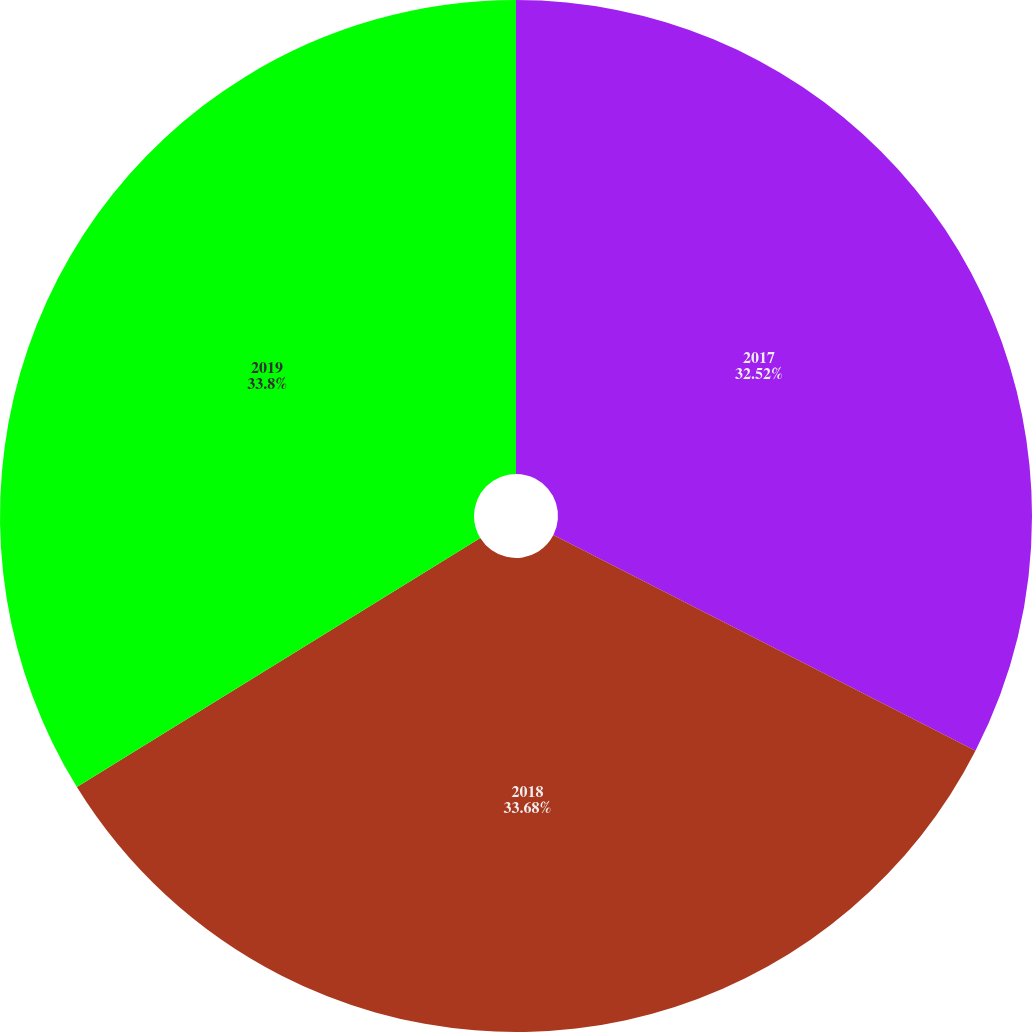<chart> <loc_0><loc_0><loc_500><loc_500><pie_chart><fcel>2017<fcel>2018<fcel>2019<nl><fcel>32.52%<fcel>33.68%<fcel>33.8%<nl></chart> 